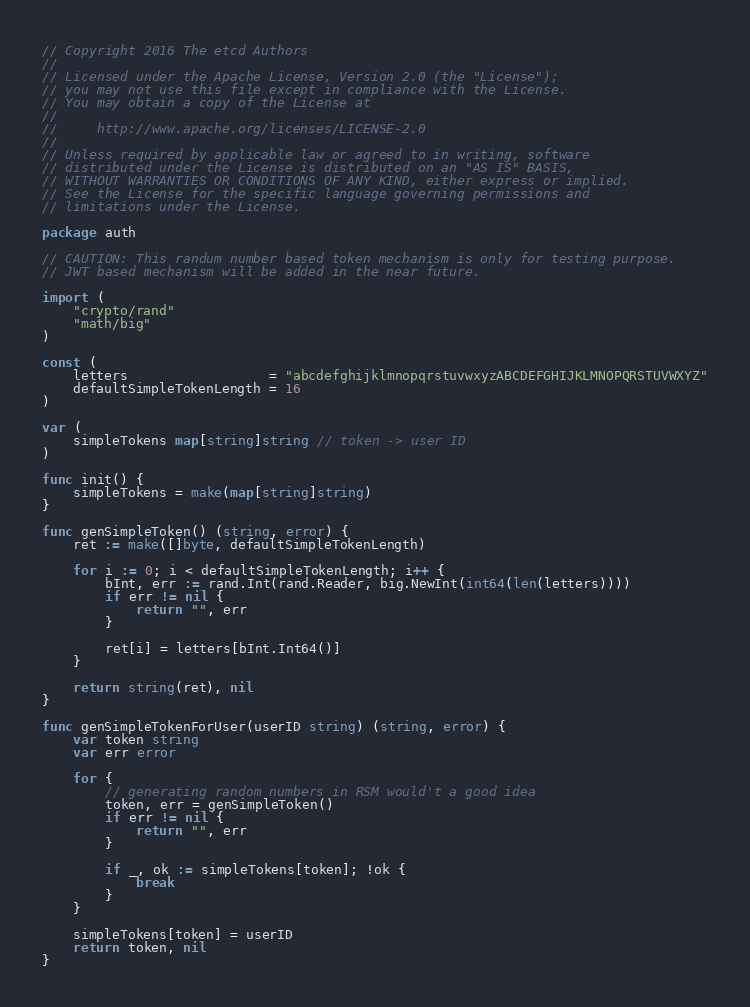Convert code to text. <code><loc_0><loc_0><loc_500><loc_500><_Go_>// Copyright 2016 The etcd Authors
//
// Licensed under the Apache License, Version 2.0 (the "License");
// you may not use this file except in compliance with the License.
// You may obtain a copy of the License at
//
//     http://www.apache.org/licenses/LICENSE-2.0
//
// Unless required by applicable law or agreed to in writing, software
// distributed under the License is distributed on an "AS IS" BASIS,
// WITHOUT WARRANTIES OR CONDITIONS OF ANY KIND, either express or implied.
// See the License for the specific language governing permissions and
// limitations under the License.

package auth

// CAUTION: This randum number based token mechanism is only for testing purpose.
// JWT based mechanism will be added in the near future.

import (
	"crypto/rand"
	"math/big"
)

const (
	letters                  = "abcdefghijklmnopqrstuvwxyzABCDEFGHIJKLMNOPQRSTUVWXYZ"
	defaultSimpleTokenLength = 16
)

var (
	simpleTokens map[string]string // token -> user ID
)

func init() {
	simpleTokens = make(map[string]string)
}

func genSimpleToken() (string, error) {
	ret := make([]byte, defaultSimpleTokenLength)

	for i := 0; i < defaultSimpleTokenLength; i++ {
		bInt, err := rand.Int(rand.Reader, big.NewInt(int64(len(letters))))
		if err != nil {
			return "", err
		}

		ret[i] = letters[bInt.Int64()]
	}

	return string(ret), nil
}

func genSimpleTokenForUser(userID string) (string, error) {
	var token string
	var err error

	for {
		// generating random numbers in RSM would't a good idea
		token, err = genSimpleToken()
		if err != nil {
			return "", err
		}

		if _, ok := simpleTokens[token]; !ok {
			break
		}
	}

	simpleTokens[token] = userID
	return token, nil
}
</code> 